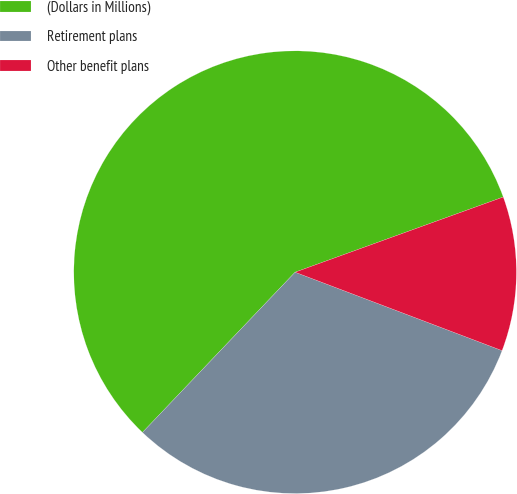Convert chart to OTSL. <chart><loc_0><loc_0><loc_500><loc_500><pie_chart><fcel>(Dollars in Millions)<fcel>Retirement plans<fcel>Other benefit plans<nl><fcel>57.37%<fcel>31.35%<fcel>11.28%<nl></chart> 